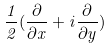<formula> <loc_0><loc_0><loc_500><loc_500>\frac { 1 } { 2 } ( \frac { \partial } { \partial x } + i \frac { \partial } { \partial y } )</formula> 